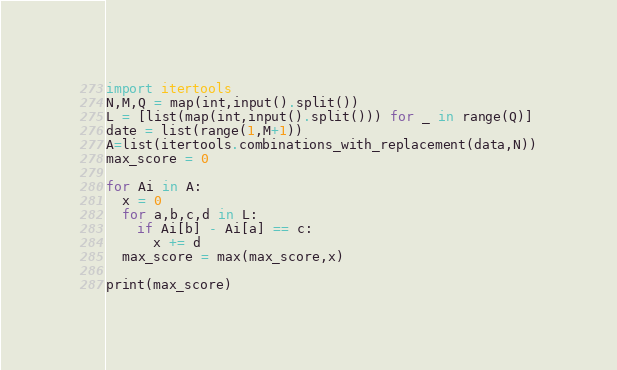Convert code to text. <code><loc_0><loc_0><loc_500><loc_500><_Python_>import itertools
N,M,Q = map(int,input().split())
L = [list(map(int,input().split())) for _ in range(Q)]
date = list(range(1,M+1))
A=list(itertools.combinations_with_replacement(data,N))
max_score = 0

for Ai in A:
  x = 0
  for a,b,c,d in L:
    if Ai[b] - Ai[a] == c:
      x += d
  max_score = max(max_score,x)
  
print(max_score)</code> 